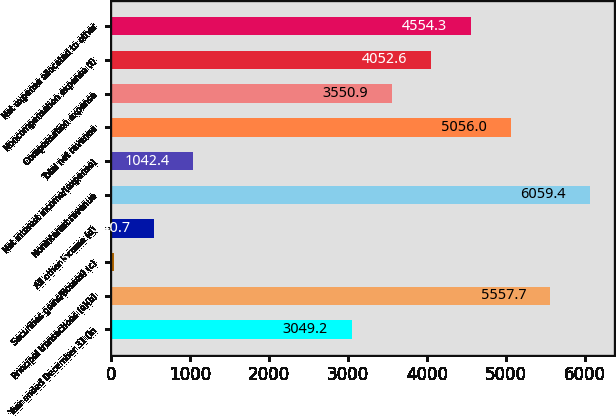Convert chart. <chart><loc_0><loc_0><loc_500><loc_500><bar_chart><fcel>Year ended December 31 (in<fcel>Principal transactions (a)(b)<fcel>Securities gains/(losses) (c)<fcel>All other income (d)<fcel>Noninterest revenue<fcel>Net interest income/(expense)<fcel>Total net revenue<fcel>Compensation expense<fcel>Noncompensation expense (f)<fcel>Net expense allocated to other<nl><fcel>3049.2<fcel>5557.7<fcel>39<fcel>540.7<fcel>6059.4<fcel>1042.4<fcel>5056<fcel>3550.9<fcel>4052.6<fcel>4554.3<nl></chart> 